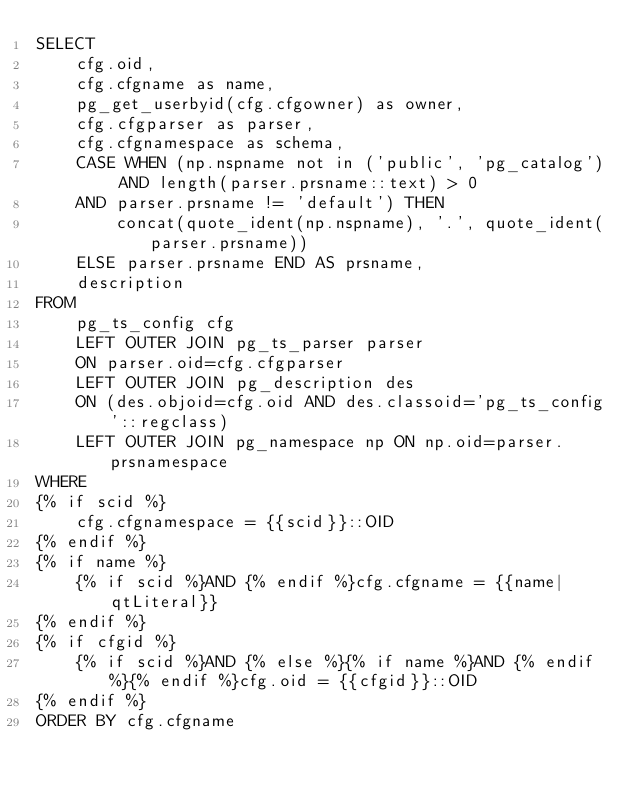<code> <loc_0><loc_0><loc_500><loc_500><_SQL_>SELECT
    cfg.oid,
    cfg.cfgname as name,
    pg_get_userbyid(cfg.cfgowner) as owner,
    cfg.cfgparser as parser,
    cfg.cfgnamespace as schema,
    CASE WHEN (np.nspname not in ('public', 'pg_catalog') AND length(parser.prsname::text) > 0
    AND parser.prsname != 'default') THEN
        concat(quote_ident(np.nspname), '.', quote_ident(parser.prsname))
    ELSE parser.prsname END AS prsname,
    description
FROM
    pg_ts_config cfg
    LEFT OUTER JOIN pg_ts_parser parser
    ON parser.oid=cfg.cfgparser
    LEFT OUTER JOIN pg_description des
    ON (des.objoid=cfg.oid AND des.classoid='pg_ts_config'::regclass)
    LEFT OUTER JOIN pg_namespace np ON np.oid=parser.prsnamespace
WHERE
{% if scid %}
    cfg.cfgnamespace = {{scid}}::OID
{% endif %}
{% if name %}
    {% if scid %}AND {% endif %}cfg.cfgname = {{name|qtLiteral}}
{% endif %}
{% if cfgid %}
    {% if scid %}AND {% else %}{% if name %}AND {% endif %}{% endif %}cfg.oid = {{cfgid}}::OID
{% endif %}
ORDER BY cfg.cfgname
</code> 